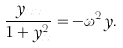<formula> <loc_0><loc_0><loc_500><loc_500>\frac { y _ { x x } } { 1 + y ^ { 2 } _ { x } } = - \omega ^ { 2 } y .</formula> 